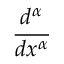Convert formula to latex. <formula><loc_0><loc_0><loc_500><loc_500>{ \frac { d ^ { \alpha } } { d x ^ { \alpha } } }</formula> 